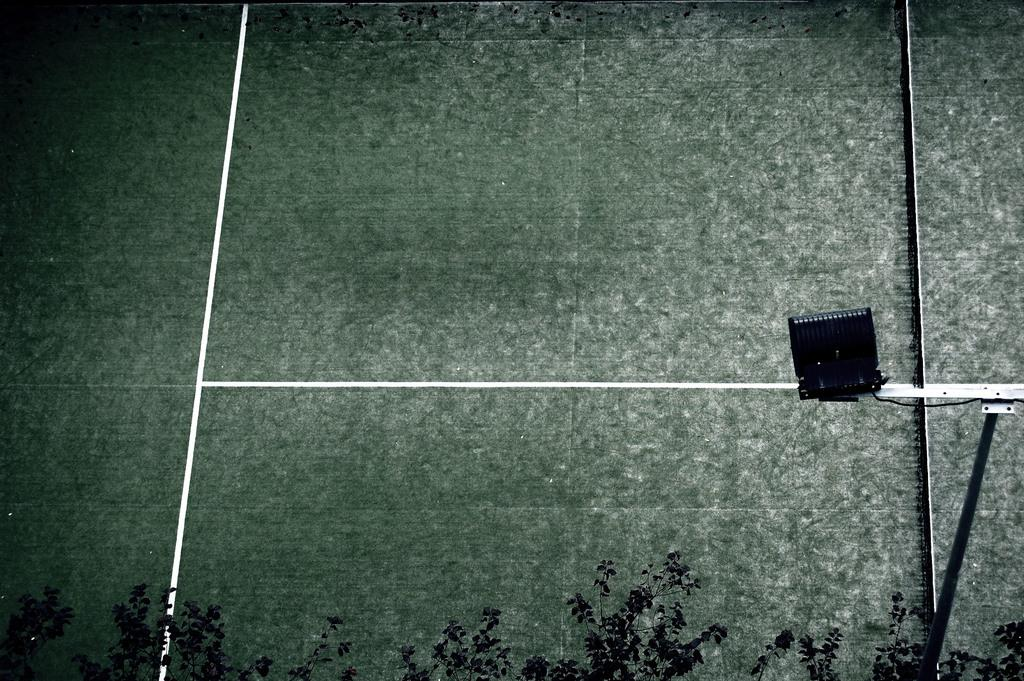What colors are present on the surface in the image? The surface in the image has a white and green color. What type of natural elements can be seen in the image? There are trees visible in the image. What is the color of the object on the surface? There is a black color object on the surface. What type of paper is being used to eat the afternoon meal in the image? There is no paper or afternoon meal present in the image. 